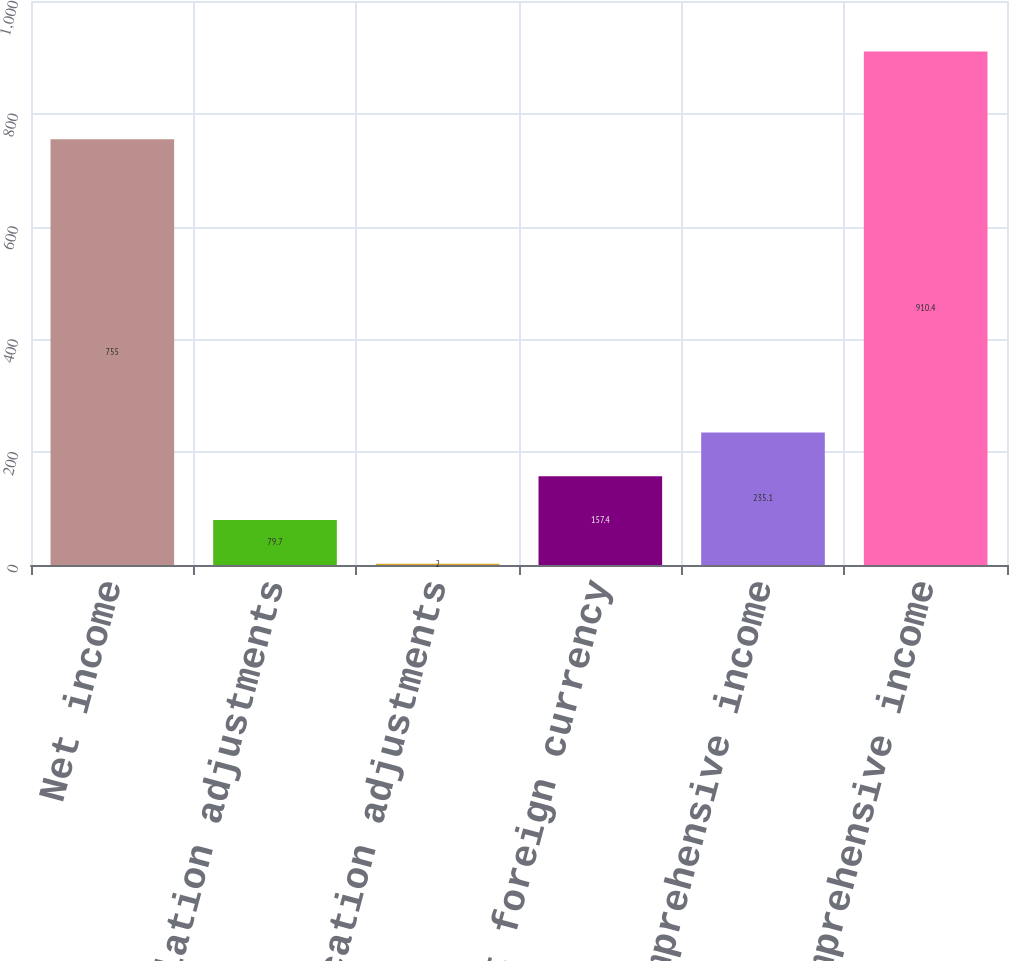<chart> <loc_0><loc_0><loc_500><loc_500><bar_chart><fcel>Net income<fcel>Translation adjustments<fcel>Reclassification adjustments<fcel>Net foreign currency<fcel>Other comprehensive income<fcel>Comprehensive income<nl><fcel>755<fcel>79.7<fcel>2<fcel>157.4<fcel>235.1<fcel>910.4<nl></chart> 